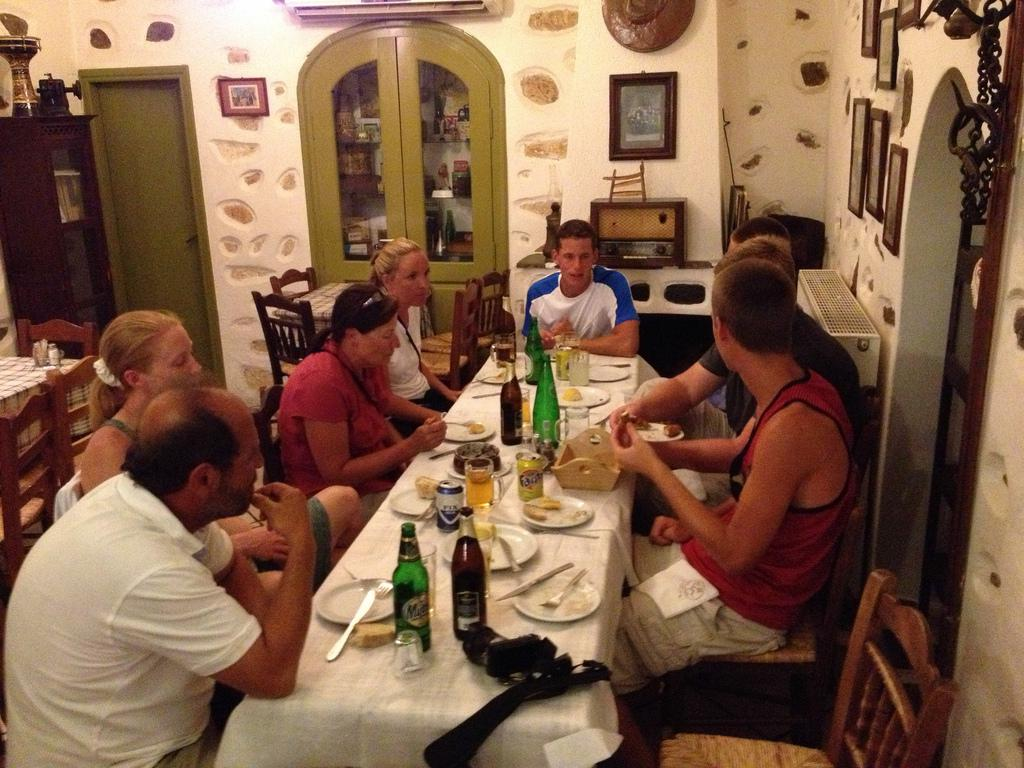Question: who is facing the camera?
Choices:
A. Man in hawaiian shirt.
B. Man in white and blue shirt.
C. Woman in black shirt.
D. Child in blue shirt.
Answer with the letter. Answer: B Question: when is this taken?
Choices:
A. Lunch time.
B. Dinner time.
C. Breakfast time.
D. Brunch time.
Answer with the letter. Answer: B Question: where are they sitting?
Choices:
A. Table.
B. Chair.
C. Sofa.
D. Couch.
Answer with the letter. Answer: A Question: what color is the tablecloth?
Choices:
A. Black.
B. Blue.
C. Yellow.
D. White.
Answer with the letter. Answer: D Question: what is white?
Choices:
A. The wall.
B. The tablecloth.
C. The apron.
D. The table.
Answer with the letter. Answer: B Question: what else matches the door that's painted green?
Choices:
A. The table.
B. Cabinet.
C. The lamp.
D. The bowl.
Answer with the letter. Answer: B Question: what is the color of sleeveless shirt the guy wearing?
Choices:
A. Black.
B. Blue.
C. White.
D. Red.
Answer with the letter. Answer: D Question: what are they drinking?
Choices:
A. Wine.
B. Coke.
C. Water.
D. Beer.
Answer with the letter. Answer: D Question: what is in the right foreground?
Choices:
A. The sofa.
B. An empty chair.
C. The plant.
D. The table.
Answer with the letter. Answer: B Question: what does the woman wearing red has on her head?
Choices:
A. A scarf.
B. A hat.
C. Glasses.
D. A wig.
Answer with the letter. Answer: C Question: how many males are there in the picture?
Choices:
A. One.
B. Five.
C. Two.
D. Three.
Answer with the letter. Answer: B Question: how many pictures are there on the wall?
Choices:
A. Seven.
B. Eight.
C. Nine.
D. Ten.
Answer with the letter. Answer: B Question: what are they drinking?
Choices:
A. Water.
B. Lemonade.
C. Coke.
D. Beer.
Answer with the letter. Answer: D Question: what are on the plates?
Choices:
A. Broccolli.
B. Potatoes.
C. Some bread rolls.
D. Corn.
Answer with the letter. Answer: C Question: how many dining tables are set with napkins?
Choices:
A. Four.
B. Two.
C. Three.
D. One.
Answer with the letter. Answer: C Question: what is the relationship between people sitting and eating dinner based on the picture?
Choices:
A. Friends.
B. Strangers.
C. Lovers.
D. Relatives.
Answer with the letter. Answer: D Question: how many other dining tables are there?
Choices:
A. Two.
B. Three.
C. Four.
D. Five.
Answer with the letter. Answer: A 